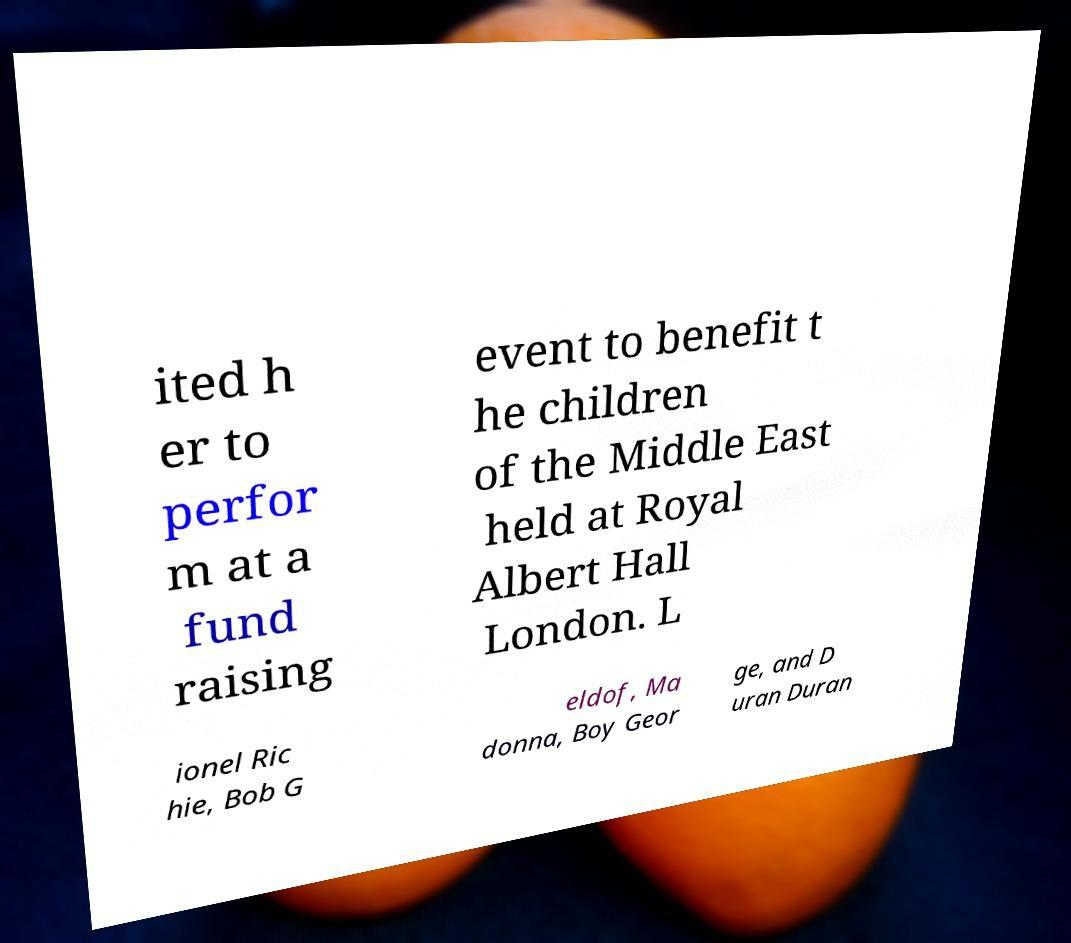Can you accurately transcribe the text from the provided image for me? ited h er to perfor m at a fund raising event to benefit t he children of the Middle East held at Royal Albert Hall London. L ionel Ric hie, Bob G eldof, Ma donna, Boy Geor ge, and D uran Duran 